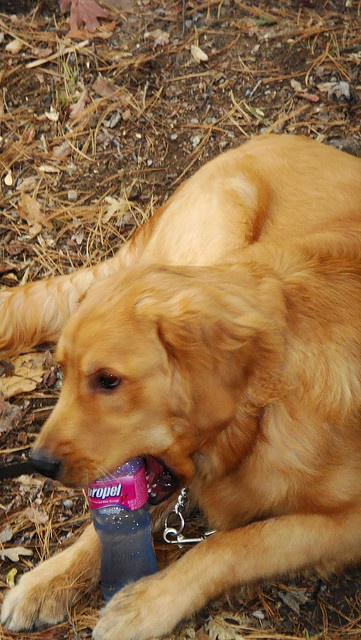Describe the objects in this image and their specific colors. I can see dog in black, brown, tan, and maroon tones and bottle in black, gray, and purple tones in this image. 